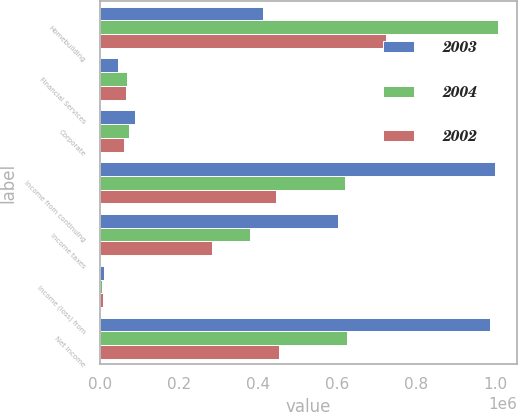<chart> <loc_0><loc_0><loc_500><loc_500><stacked_bar_chart><ecel><fcel>Homebuilding<fcel>Financial Services<fcel>Corporate<fcel>Income from continuing<fcel>Income taxes<fcel>Income (loss) from<fcel>Net income<nl><fcel>2003<fcel>412080<fcel>47429<fcel>90685<fcel>998008<fcel>602529<fcel>11467<fcel>986541<nl><fcel>2004<fcel>1.00512e+06<fcel>68846<fcel>75351<fcel>619243<fcel>379376<fcel>5391<fcel>624634<nl><fcel>2002<fcel>724369<fcel>66723<fcel>61968<fcel>444785<fcel>284339<fcel>8860<fcel>453645<nl></chart> 